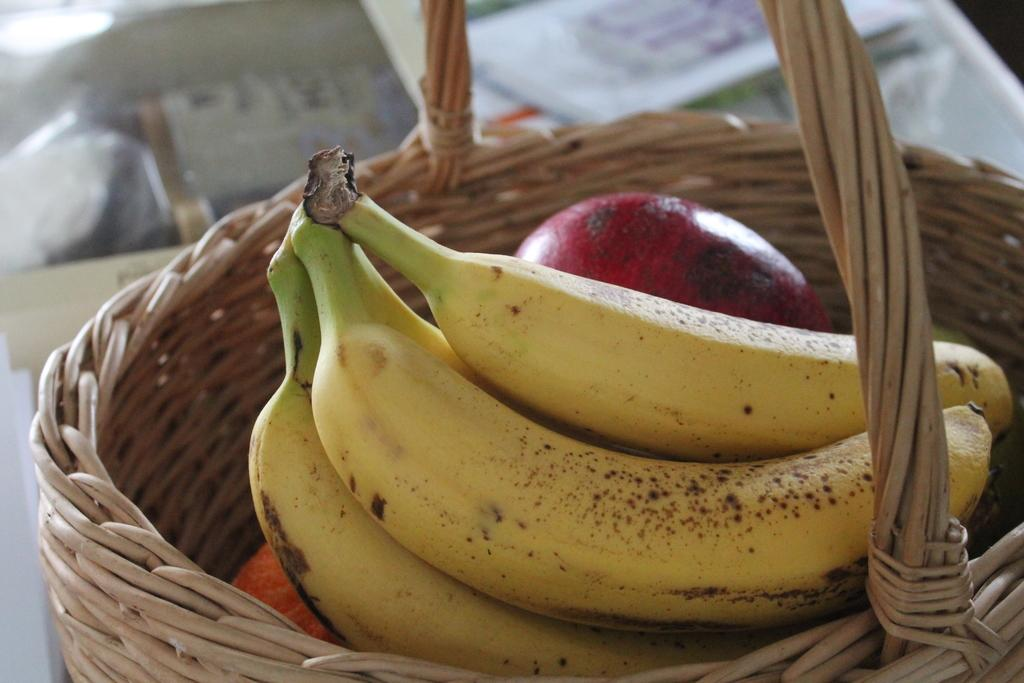What type of fruit can be seen in the image? There are bananas in the image. What category do the bananas belong to? The bananas are fruits. How are the fruits arranged in the image? The fruits are in a basket. How many kittens are sitting on the bananas in the image? There are no kittens present in the image; it only features bananas in a basket. 